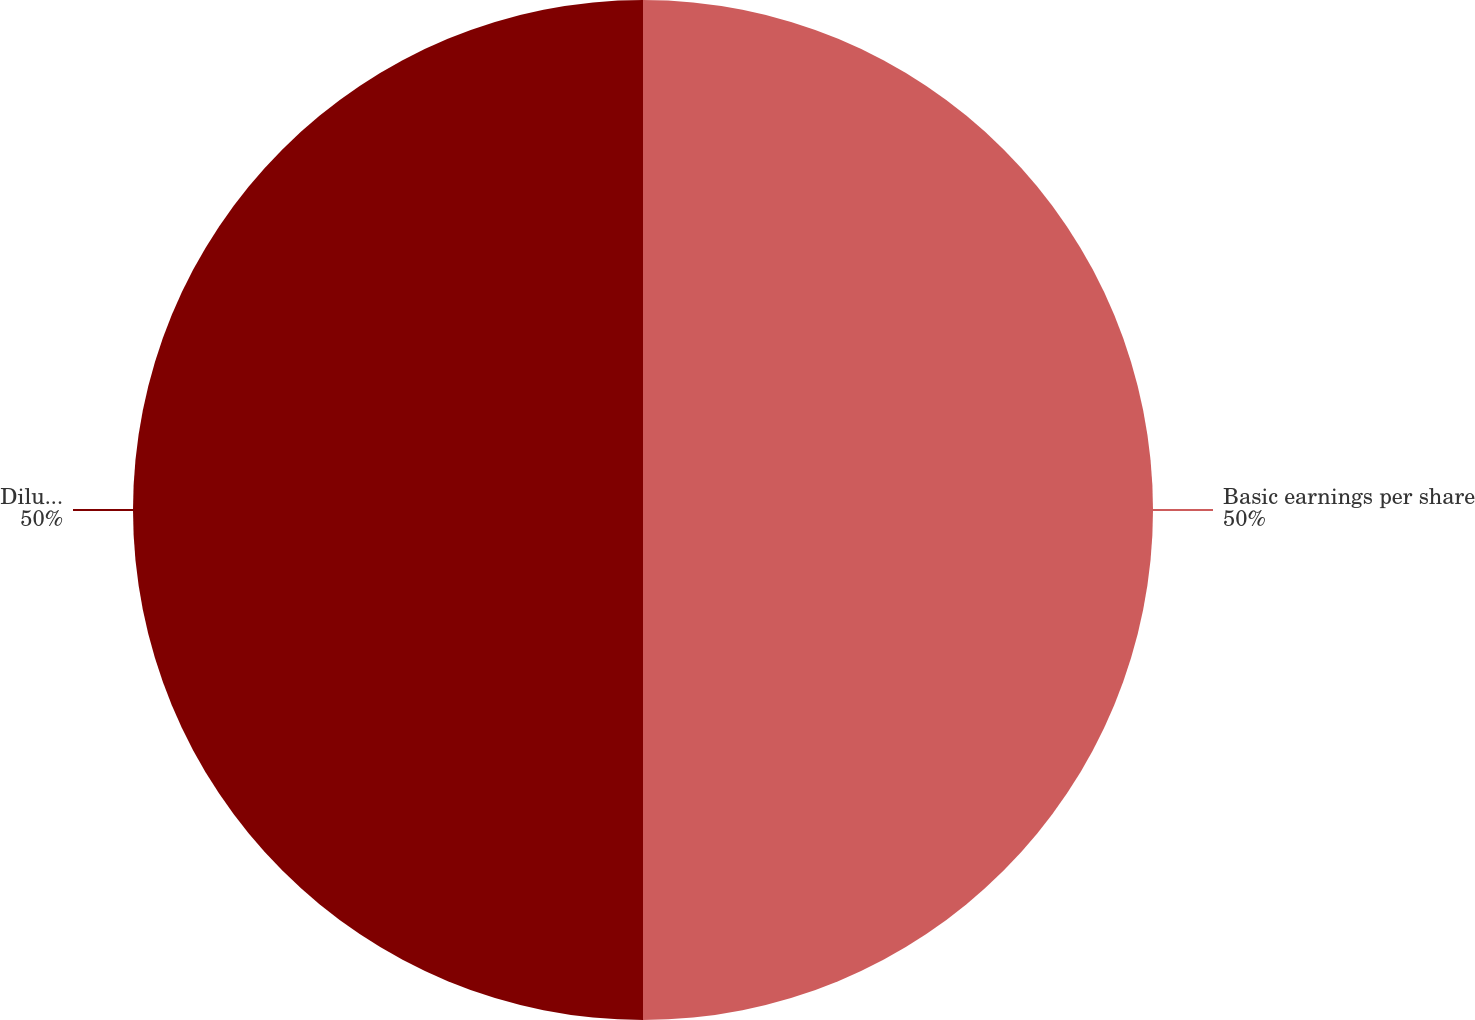Convert chart. <chart><loc_0><loc_0><loc_500><loc_500><pie_chart><fcel>Basic earnings per share<fcel>Diluted earnings per share<nl><fcel>50.0%<fcel>50.0%<nl></chart> 